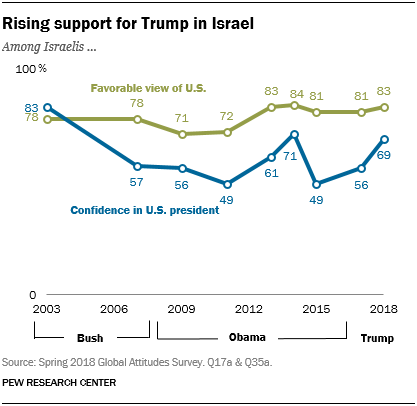Highlight a few significant elements in this photo. The color of a graph whose rightmost value is 83 is green. The ratio of the peak value of the green to blue graph is 84:83, and the answer is yes. 